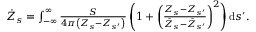<formula> <loc_0><loc_0><loc_500><loc_500>\begin{array} { r } { \dot { Z } _ { s } = \int _ { - \infty } ^ { \infty } \frac { S } { 4 \pi \left ( Z _ { s } - Z _ { s ^ { \prime } } \right ) } \left ( 1 + \left ( \frac { Z _ { s } - Z _ { s ^ { \prime } } } { \bar { Z } _ { s } - \bar { Z } _ { s ^ { \prime } } } \right ) ^ { 2 } \right ) d s ^ { \prime } . } \end{array}</formula> 